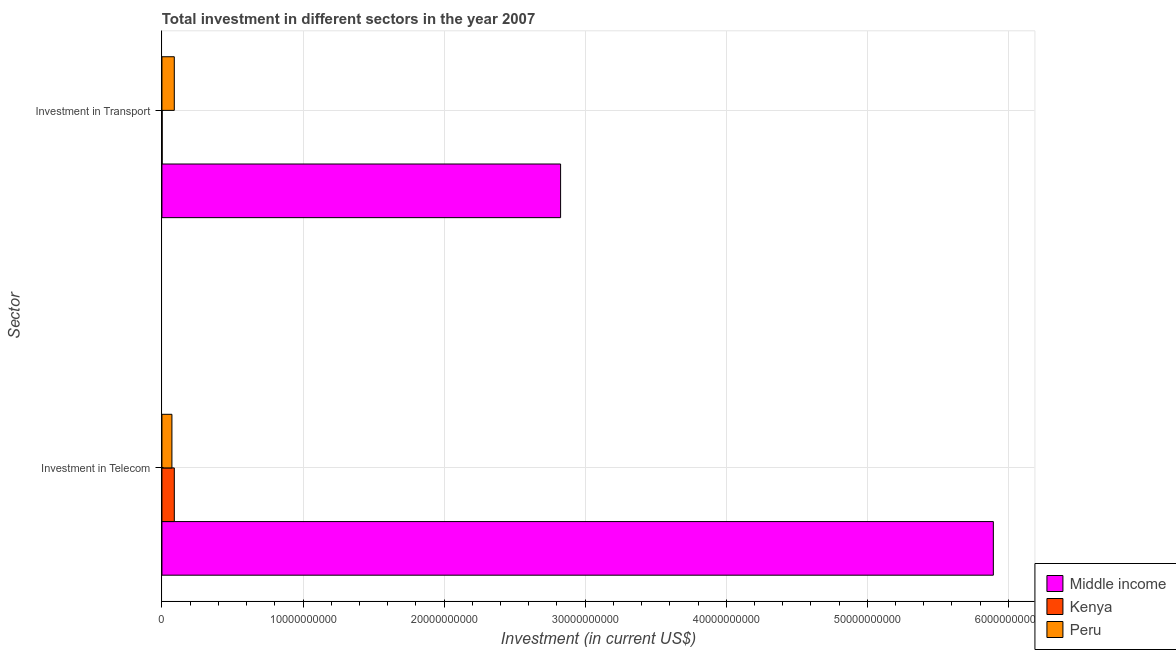How many groups of bars are there?
Your response must be concise. 2. Are the number of bars per tick equal to the number of legend labels?
Ensure brevity in your answer.  Yes. Are the number of bars on each tick of the Y-axis equal?
Ensure brevity in your answer.  Yes. How many bars are there on the 1st tick from the top?
Your answer should be compact. 3. How many bars are there on the 2nd tick from the bottom?
Give a very brief answer. 3. What is the label of the 1st group of bars from the top?
Give a very brief answer. Investment in Transport. What is the investment in transport in Kenya?
Provide a short and direct response. 1.50e+07. Across all countries, what is the maximum investment in telecom?
Give a very brief answer. 5.89e+1. Across all countries, what is the minimum investment in transport?
Keep it short and to the point. 1.50e+07. In which country was the investment in transport minimum?
Give a very brief answer. Kenya. What is the total investment in transport in the graph?
Provide a succinct answer. 2.91e+1. What is the difference between the investment in transport in Peru and that in Middle income?
Give a very brief answer. -2.74e+1. What is the difference between the investment in transport in Kenya and the investment in telecom in Peru?
Offer a terse response. -6.92e+08. What is the average investment in telecom per country?
Your response must be concise. 2.02e+1. What is the difference between the investment in transport and investment in telecom in Kenya?
Give a very brief answer. -8.62e+08. What is the ratio of the investment in telecom in Peru to that in Kenya?
Ensure brevity in your answer.  0.81. Is the investment in transport in Peru less than that in Kenya?
Ensure brevity in your answer.  No. In how many countries, is the investment in telecom greater than the average investment in telecom taken over all countries?
Your answer should be compact. 1. What does the 1st bar from the bottom in Investment in Transport represents?
Your answer should be very brief. Middle income. How many bars are there?
Provide a short and direct response. 6. Are all the bars in the graph horizontal?
Make the answer very short. Yes. What is the difference between two consecutive major ticks on the X-axis?
Your response must be concise. 1.00e+1. What is the title of the graph?
Keep it short and to the point. Total investment in different sectors in the year 2007. Does "Chad" appear as one of the legend labels in the graph?
Provide a succinct answer. No. What is the label or title of the X-axis?
Offer a very short reply. Investment (in current US$). What is the label or title of the Y-axis?
Ensure brevity in your answer.  Sector. What is the Investment (in current US$) of Middle income in Investment in Telecom?
Make the answer very short. 5.89e+1. What is the Investment (in current US$) of Kenya in Investment in Telecom?
Offer a very short reply. 8.77e+08. What is the Investment (in current US$) of Peru in Investment in Telecom?
Your answer should be compact. 7.07e+08. What is the Investment (in current US$) in Middle income in Investment in Transport?
Keep it short and to the point. 2.83e+1. What is the Investment (in current US$) in Kenya in Investment in Transport?
Provide a short and direct response. 1.50e+07. What is the Investment (in current US$) of Peru in Investment in Transport?
Keep it short and to the point. 8.76e+08. Across all Sector, what is the maximum Investment (in current US$) in Middle income?
Provide a succinct answer. 5.89e+1. Across all Sector, what is the maximum Investment (in current US$) of Kenya?
Make the answer very short. 8.77e+08. Across all Sector, what is the maximum Investment (in current US$) of Peru?
Your answer should be very brief. 8.76e+08. Across all Sector, what is the minimum Investment (in current US$) of Middle income?
Provide a short and direct response. 2.83e+1. Across all Sector, what is the minimum Investment (in current US$) in Kenya?
Ensure brevity in your answer.  1.50e+07. Across all Sector, what is the minimum Investment (in current US$) of Peru?
Your answer should be very brief. 7.07e+08. What is the total Investment (in current US$) of Middle income in the graph?
Keep it short and to the point. 8.72e+1. What is the total Investment (in current US$) in Kenya in the graph?
Your response must be concise. 8.92e+08. What is the total Investment (in current US$) of Peru in the graph?
Provide a succinct answer. 1.58e+09. What is the difference between the Investment (in current US$) of Middle income in Investment in Telecom and that in Investment in Transport?
Your response must be concise. 3.07e+1. What is the difference between the Investment (in current US$) in Kenya in Investment in Telecom and that in Investment in Transport?
Your answer should be compact. 8.62e+08. What is the difference between the Investment (in current US$) in Peru in Investment in Telecom and that in Investment in Transport?
Provide a short and direct response. -1.69e+08. What is the difference between the Investment (in current US$) of Middle income in Investment in Telecom and the Investment (in current US$) of Kenya in Investment in Transport?
Provide a short and direct response. 5.89e+1. What is the difference between the Investment (in current US$) in Middle income in Investment in Telecom and the Investment (in current US$) in Peru in Investment in Transport?
Provide a short and direct response. 5.81e+1. What is the difference between the Investment (in current US$) in Kenya in Investment in Telecom and the Investment (in current US$) in Peru in Investment in Transport?
Your response must be concise. 1.20e+06. What is the average Investment (in current US$) in Middle income per Sector?
Provide a succinct answer. 4.36e+1. What is the average Investment (in current US$) of Kenya per Sector?
Offer a terse response. 4.46e+08. What is the average Investment (in current US$) of Peru per Sector?
Offer a very short reply. 7.92e+08. What is the difference between the Investment (in current US$) of Middle income and Investment (in current US$) of Kenya in Investment in Telecom?
Keep it short and to the point. 5.81e+1. What is the difference between the Investment (in current US$) in Middle income and Investment (in current US$) in Peru in Investment in Telecom?
Offer a very short reply. 5.82e+1. What is the difference between the Investment (in current US$) of Kenya and Investment (in current US$) of Peru in Investment in Telecom?
Ensure brevity in your answer.  1.70e+08. What is the difference between the Investment (in current US$) of Middle income and Investment (in current US$) of Kenya in Investment in Transport?
Make the answer very short. 2.82e+1. What is the difference between the Investment (in current US$) of Middle income and Investment (in current US$) of Peru in Investment in Transport?
Your answer should be very brief. 2.74e+1. What is the difference between the Investment (in current US$) in Kenya and Investment (in current US$) in Peru in Investment in Transport?
Ensure brevity in your answer.  -8.61e+08. What is the ratio of the Investment (in current US$) of Middle income in Investment in Telecom to that in Investment in Transport?
Keep it short and to the point. 2.09. What is the ratio of the Investment (in current US$) in Kenya in Investment in Telecom to that in Investment in Transport?
Give a very brief answer. 58.47. What is the ratio of the Investment (in current US$) in Peru in Investment in Telecom to that in Investment in Transport?
Offer a terse response. 0.81. What is the difference between the highest and the second highest Investment (in current US$) in Middle income?
Give a very brief answer. 3.07e+1. What is the difference between the highest and the second highest Investment (in current US$) of Kenya?
Provide a short and direct response. 8.62e+08. What is the difference between the highest and the second highest Investment (in current US$) in Peru?
Provide a succinct answer. 1.69e+08. What is the difference between the highest and the lowest Investment (in current US$) in Middle income?
Offer a very short reply. 3.07e+1. What is the difference between the highest and the lowest Investment (in current US$) in Kenya?
Ensure brevity in your answer.  8.62e+08. What is the difference between the highest and the lowest Investment (in current US$) in Peru?
Your answer should be very brief. 1.69e+08. 